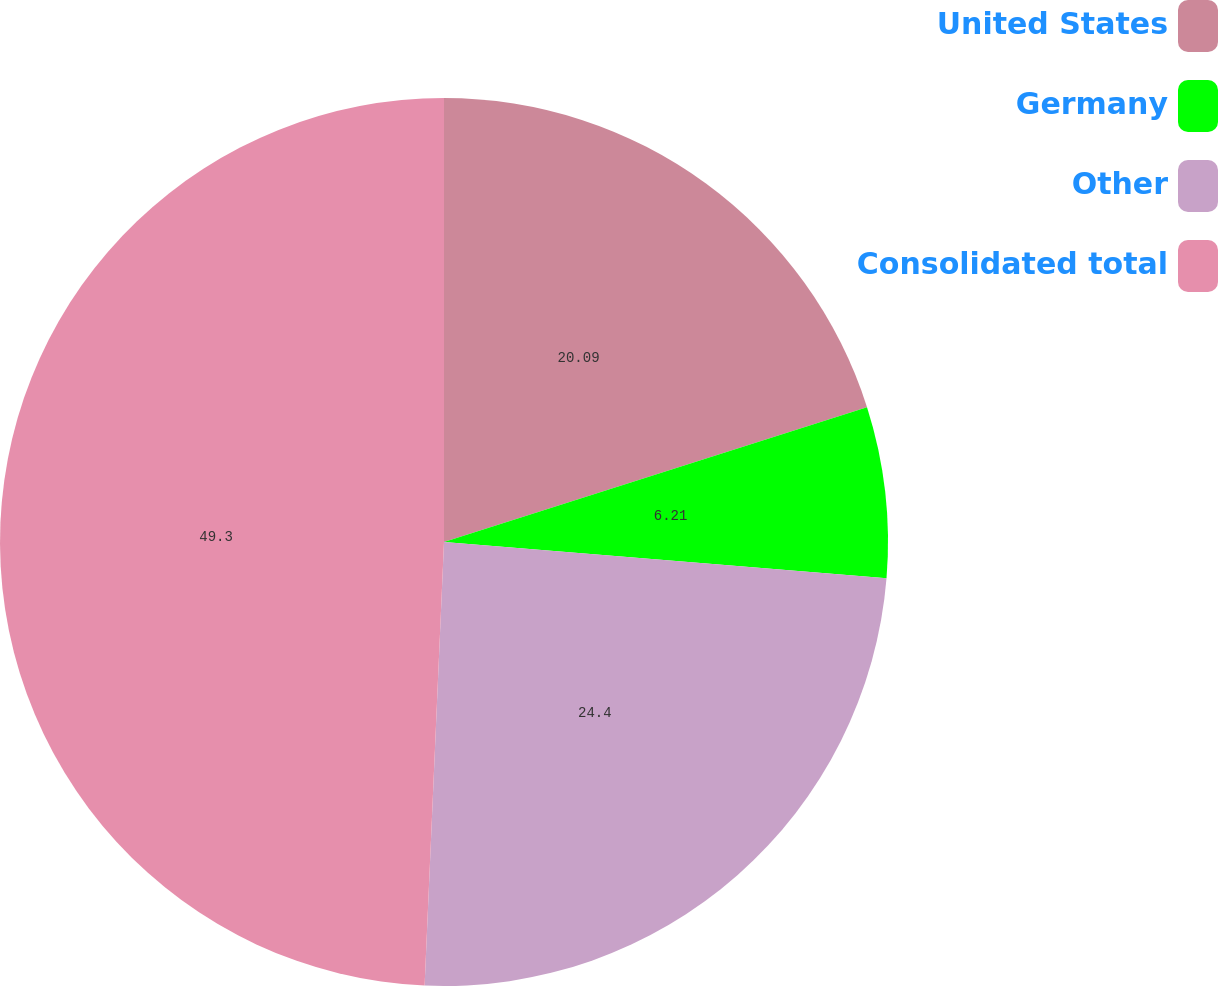<chart> <loc_0><loc_0><loc_500><loc_500><pie_chart><fcel>United States<fcel>Germany<fcel>Other<fcel>Consolidated total<nl><fcel>20.09%<fcel>6.21%<fcel>24.4%<fcel>49.31%<nl></chart> 